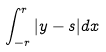Convert formula to latex. <formula><loc_0><loc_0><loc_500><loc_500>\int _ { - r } ^ { r } | y - s | d x</formula> 